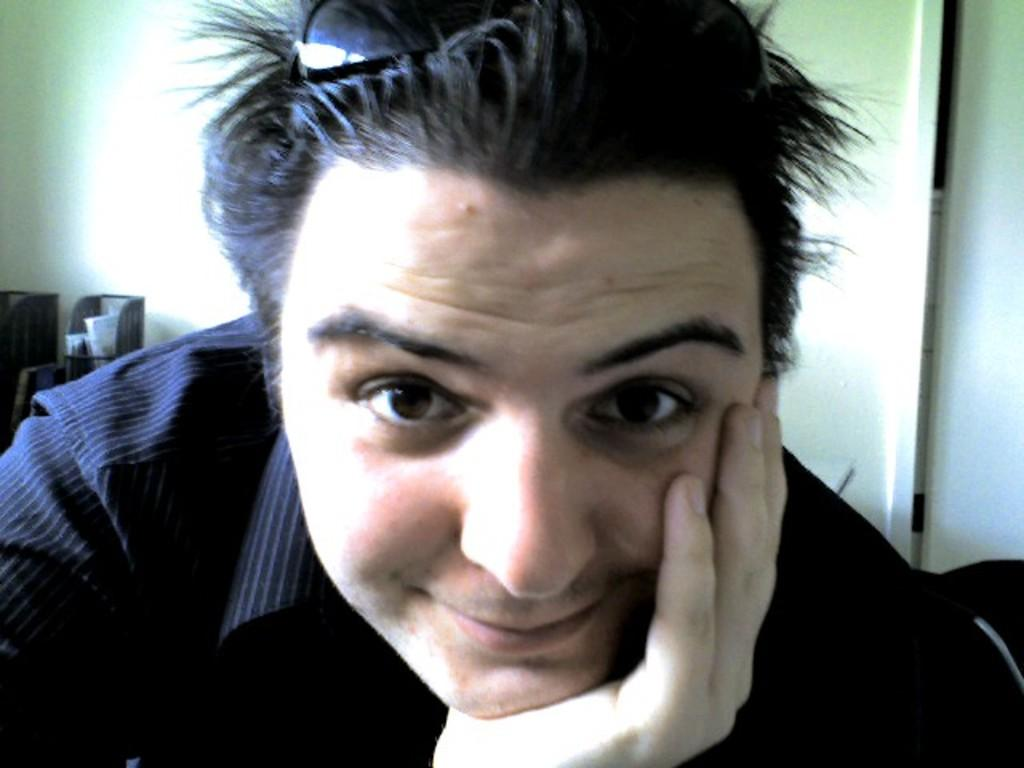Who is present in the image? There is a man in the image. What is the man's facial expression? The man is smiling. What accessory is the man wearing? The man is wearing shades. What can be seen in the background of the image? There is a wall in the background of the image. Can you describe any other objects in the image? There are unspecified objects in the image. What type of property is the man holding in the image? There is no property visible in the image; the man is simply wearing shades and smiling. What color is the flag in the image? There is no flag present in the image. 